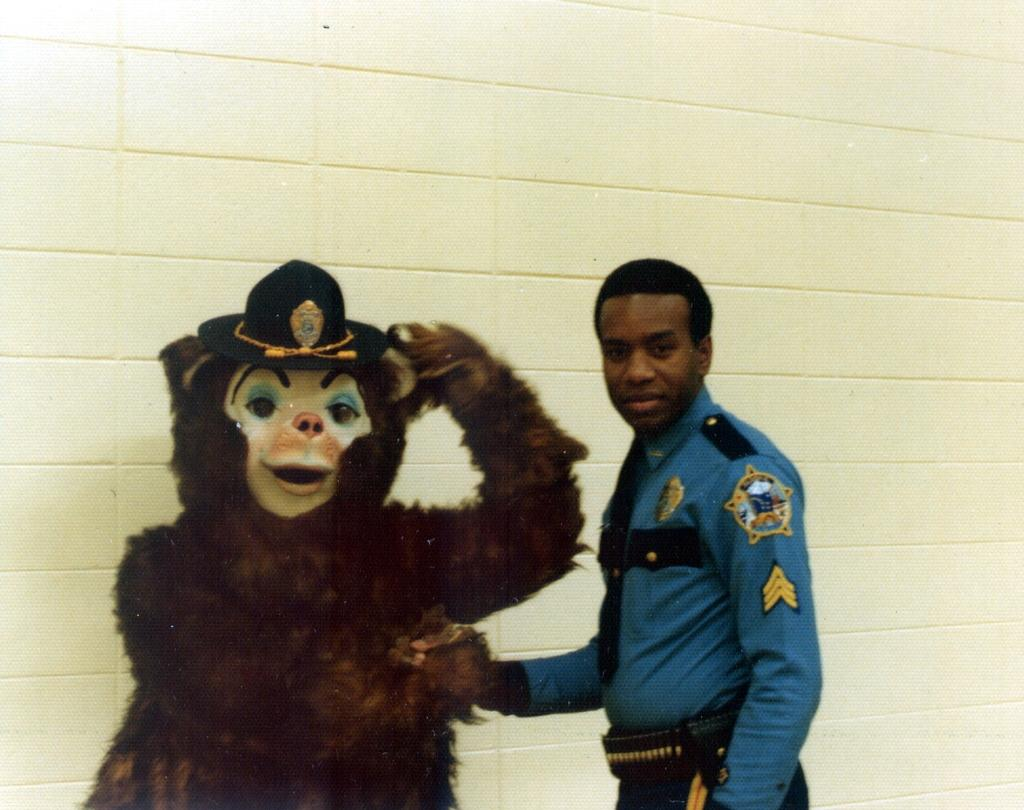What is the main subject of the image? There is a man in the image. What is the man doing in the image? The man is waving his hand. Are there any other people or characters in the image? Yes, there is a person dressed as a monkey in the image. What type of chicken can be seen in the image? There is no chicken present in the image. Can you describe the owl's behavior in the image? There is no owl present in the image. 